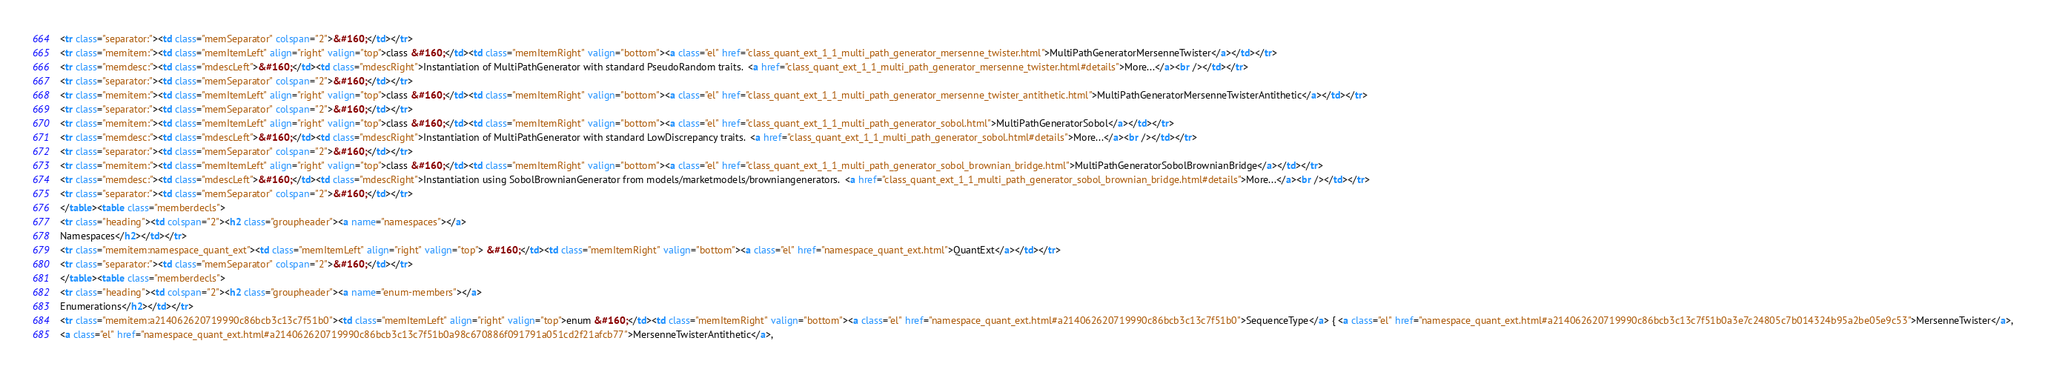<code> <loc_0><loc_0><loc_500><loc_500><_HTML_><tr class="separator:"><td class="memSeparator" colspan="2">&#160;</td></tr>
<tr class="memitem:"><td class="memItemLeft" align="right" valign="top">class &#160;</td><td class="memItemRight" valign="bottom"><a class="el" href="class_quant_ext_1_1_multi_path_generator_mersenne_twister.html">MultiPathGeneratorMersenneTwister</a></td></tr>
<tr class="memdesc:"><td class="mdescLeft">&#160;</td><td class="mdescRight">Instantiation of MultiPathGenerator with standard PseudoRandom traits.  <a href="class_quant_ext_1_1_multi_path_generator_mersenne_twister.html#details">More...</a><br /></td></tr>
<tr class="separator:"><td class="memSeparator" colspan="2">&#160;</td></tr>
<tr class="memitem:"><td class="memItemLeft" align="right" valign="top">class &#160;</td><td class="memItemRight" valign="bottom"><a class="el" href="class_quant_ext_1_1_multi_path_generator_mersenne_twister_antithetic.html">MultiPathGeneratorMersenneTwisterAntithetic</a></td></tr>
<tr class="separator:"><td class="memSeparator" colspan="2">&#160;</td></tr>
<tr class="memitem:"><td class="memItemLeft" align="right" valign="top">class &#160;</td><td class="memItemRight" valign="bottom"><a class="el" href="class_quant_ext_1_1_multi_path_generator_sobol.html">MultiPathGeneratorSobol</a></td></tr>
<tr class="memdesc:"><td class="mdescLeft">&#160;</td><td class="mdescRight">Instantiation of MultiPathGenerator with standard LowDiscrepancy traits.  <a href="class_quant_ext_1_1_multi_path_generator_sobol.html#details">More...</a><br /></td></tr>
<tr class="separator:"><td class="memSeparator" colspan="2">&#160;</td></tr>
<tr class="memitem:"><td class="memItemLeft" align="right" valign="top">class &#160;</td><td class="memItemRight" valign="bottom"><a class="el" href="class_quant_ext_1_1_multi_path_generator_sobol_brownian_bridge.html">MultiPathGeneratorSobolBrownianBridge</a></td></tr>
<tr class="memdesc:"><td class="mdescLeft">&#160;</td><td class="mdescRight">Instantiation using SobolBrownianGenerator from models/marketmodels/browniangenerators.  <a href="class_quant_ext_1_1_multi_path_generator_sobol_brownian_bridge.html#details">More...</a><br /></td></tr>
<tr class="separator:"><td class="memSeparator" colspan="2">&#160;</td></tr>
</table><table class="memberdecls">
<tr class="heading"><td colspan="2"><h2 class="groupheader"><a name="namespaces"></a>
Namespaces</h2></td></tr>
<tr class="memitem:namespace_quant_ext"><td class="memItemLeft" align="right" valign="top"> &#160;</td><td class="memItemRight" valign="bottom"><a class="el" href="namespace_quant_ext.html">QuantExt</a></td></tr>
<tr class="separator:"><td class="memSeparator" colspan="2">&#160;</td></tr>
</table><table class="memberdecls">
<tr class="heading"><td colspan="2"><h2 class="groupheader"><a name="enum-members"></a>
Enumerations</h2></td></tr>
<tr class="memitem:a214062620719990c86bcb3c13c7f51b0"><td class="memItemLeft" align="right" valign="top">enum &#160;</td><td class="memItemRight" valign="bottom"><a class="el" href="namespace_quant_ext.html#a214062620719990c86bcb3c13c7f51b0">SequenceType</a> { <a class="el" href="namespace_quant_ext.html#a214062620719990c86bcb3c13c7f51b0a3e7c24805c7b014324b95a2be05e9c53">MersenneTwister</a>, 
<a class="el" href="namespace_quant_ext.html#a214062620719990c86bcb3c13c7f51b0a98c670886f091791a051cd2f21afcb77">MersenneTwisterAntithetic</a>, </code> 